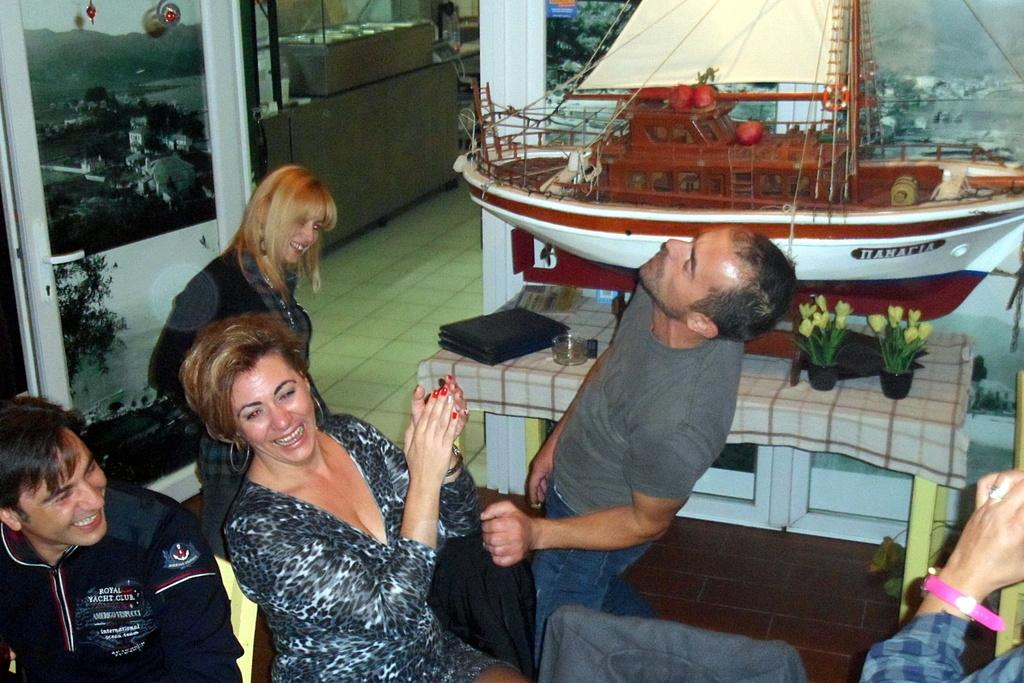What can be seen in the foreground of the image? There are people in the foreground of the image. What type of objects are present in the image? There are plant pots, a model of a ship, and other objects in the image. Can you describe the door in the image? Yes, there is a door in the image. What is visible in the background of the image? The background of the image appears to include mountains and the sky. How many flocks of birds can be seen flying over the mountains in the image? There are no flocks of birds visible in the image; it only shows people, plant pots, a model of a ship, other objects, a door, mountains, and the sky. What is the mother of the people in the image doing? The provided facts do not mention a mother or any specific actions of the people in the image. 